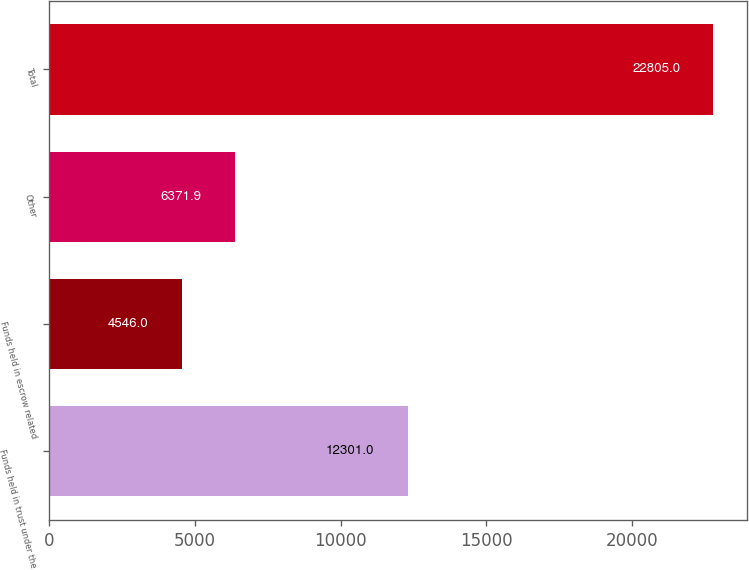Convert chart to OTSL. <chart><loc_0><loc_0><loc_500><loc_500><bar_chart><fcel>Funds held in trust under the<fcel>Funds held in escrow related<fcel>Other<fcel>Total<nl><fcel>12301<fcel>4546<fcel>6371.9<fcel>22805<nl></chart> 